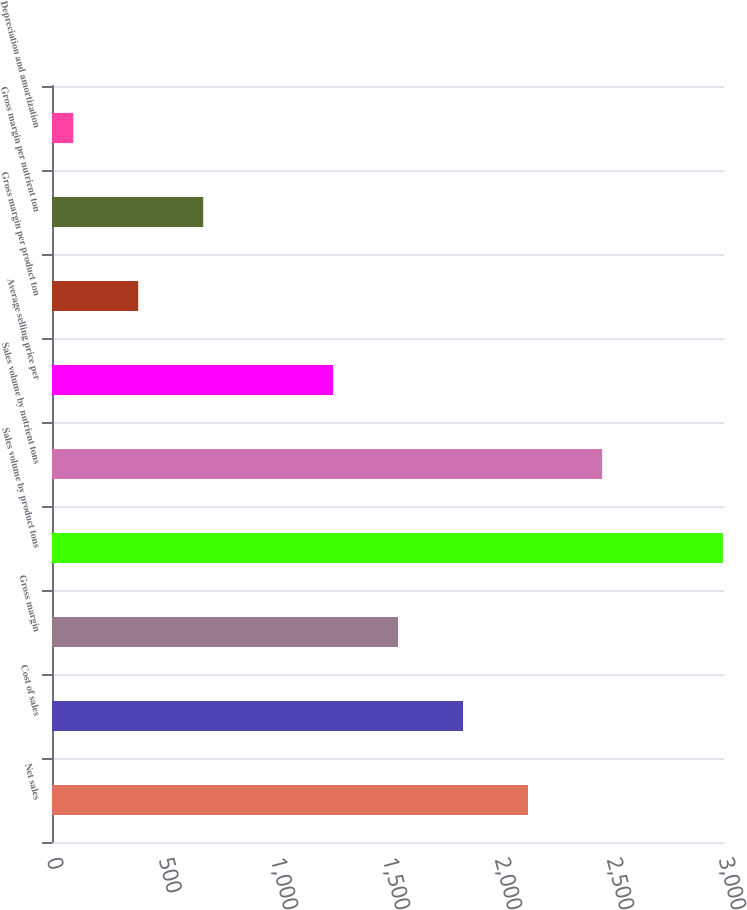Convert chart. <chart><loc_0><loc_0><loc_500><loc_500><bar_chart><fcel>Net sales<fcel>Cost of sales<fcel>Gross margin<fcel>Sales volume by product tons<fcel>Sales volume by nutrient tons<fcel>Average selling price per<fcel>Gross margin per product ton<fcel>Gross margin per nutrient ton<fcel>Depreciation and amortization<nl><fcel>2125<fcel>1835<fcel>1545<fcel>2995<fcel>2456<fcel>1255<fcel>385<fcel>675<fcel>95<nl></chart> 